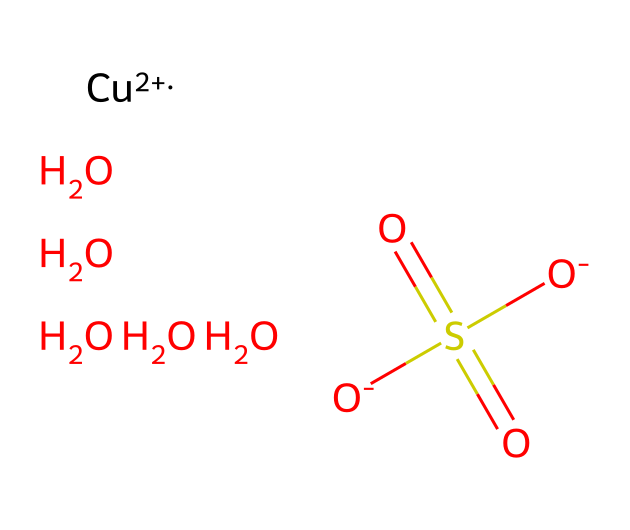What is the central metal atom in this compound? The chemical includes a copper ion represented by [Cu+2], which indicates the presence of copper as a metal core in the coordination compound.
Answer: copper How many oxygen atoms are present in this structure? The chemical structure contains five oxygen atoms. There are four in the sulfate group (O)S(=O)(=O)[O-] and one in the additional oxygen- (O) molecule, totaling five.
Answer: five What is the oxidation state of copper in this compound? The notation [Cu+2] indicates that copper is in the +2 oxidation state in this coordination compound.
Answer: +2 What type of ligand is the sulfate group in this compound? The sulfate group is classified as a bidentate ligand because it can bind to the metal at two points due to its multiple oxygen atoms holding lone pairs.
Answer: bidentate What geometry does copper(II) sulfate adopt in coordination complexes? Coordination compounds like copper(II) sulfate typically adopt an octahedral geometry due to the six coordination sites available for ligands around the copper ion.
Answer: octahedral 